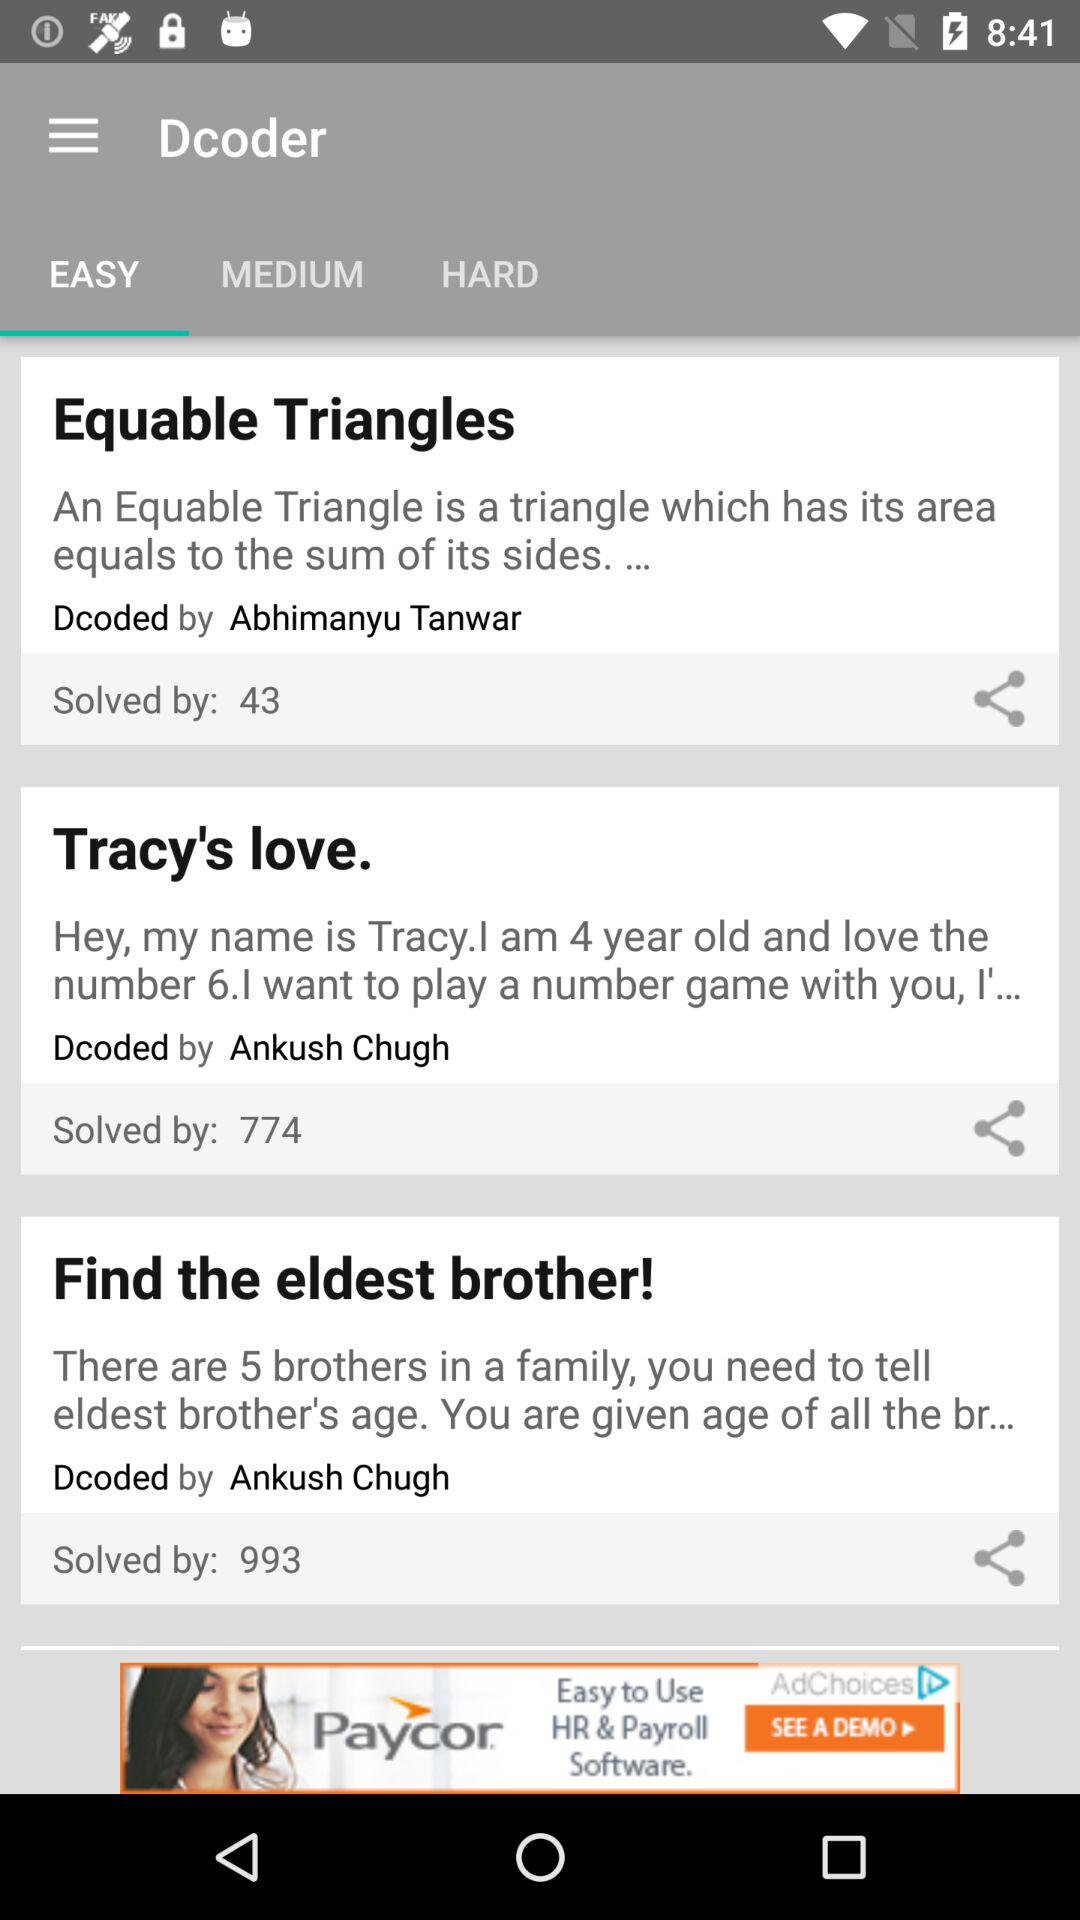How many people have solved "Equable Triangles"? There are 43 people who have solved "Equable Triangles". 